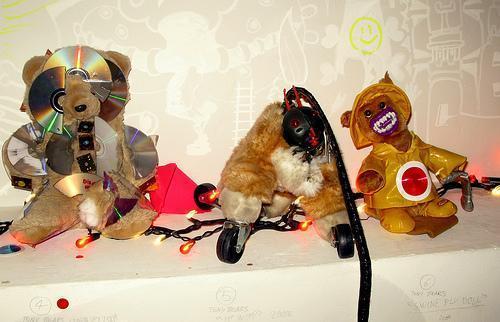How many dolls are in the pic?
Give a very brief answer. 3. 